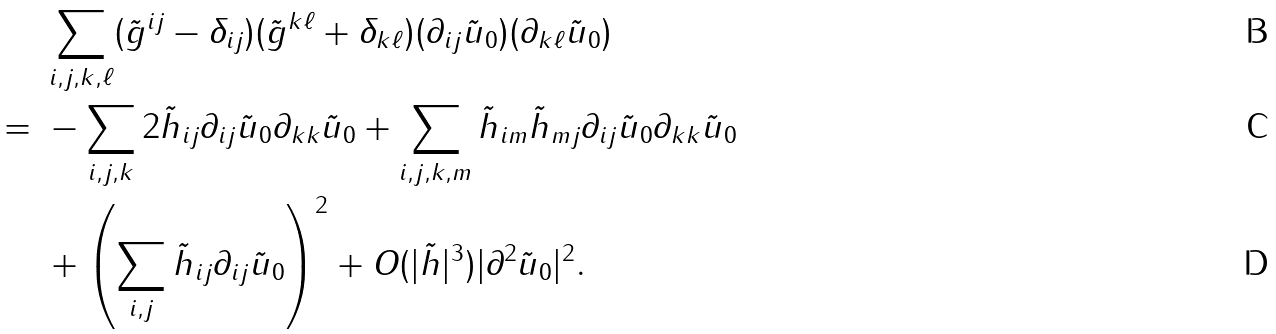<formula> <loc_0><loc_0><loc_500><loc_500>& \ \sum _ { i , j , k , \ell } ( \tilde { g } ^ { i j } - \delta _ { i j } ) ( \tilde { g } ^ { k \ell } + \delta _ { k \ell } ) ( \partial _ { i j } \tilde { u } _ { 0 } ) ( \partial _ { k \ell } \tilde { u } _ { 0 } ) \\ = & \ - \sum _ { i , j , k } 2 \tilde { h } _ { i j } \partial _ { i j } \tilde { u } _ { 0 } \partial _ { k k } \tilde { u } _ { 0 } + \sum _ { i , j , k , m } \tilde { h } _ { i m } \tilde { h } _ { m j } \partial _ { i j } \tilde { u } _ { 0 } \partial _ { k k } \tilde { u } _ { 0 } \\ & \ + \left ( \sum _ { i , j } \tilde { h } _ { i j } \partial _ { i j } \tilde { u } _ { 0 } \right ) ^ { 2 } + O ( | \tilde { h } | ^ { 3 } ) | \partial ^ { 2 } \tilde { u } _ { 0 } | ^ { 2 } .</formula> 